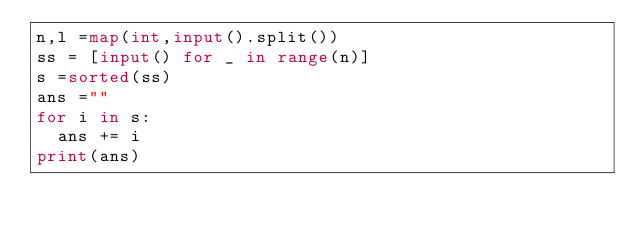<code> <loc_0><loc_0><loc_500><loc_500><_Python_>n,l =map(int,input().split())
ss = [input() for _ in range(n)]
s =sorted(ss)
ans =""
for i in s:
  ans += i
print(ans)</code> 